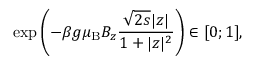Convert formula to latex. <formula><loc_0><loc_0><loc_500><loc_500>\exp \left ( - \beta g { { \mu _ { B } } } B _ { z } \frac { \sqrt { 2 s } | z | } { 1 + | z | ^ { 2 } } \right ) \in [ 0 ; 1 ] ,</formula> 